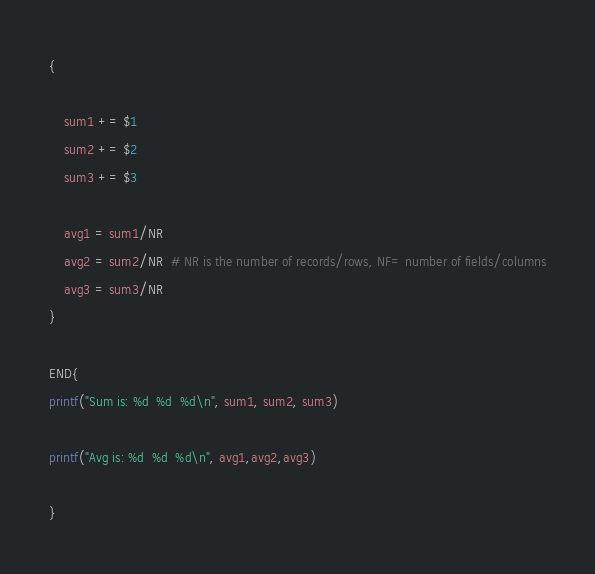Convert code to text. <code><loc_0><loc_0><loc_500><loc_500><_Awk_>

{

	sum1 += $1
	sum2 += $2
	sum3 += $3

	avg1 = sum1/NR
	avg2 = sum2/NR  # NR is the number of records/rows, NF= number of fields/columns
	avg3 = sum3/NR
}

END{
printf("Sum is: %d  %d  %d\n", sum1, sum2, sum3)

printf("Avg is: %d  %d  %d\n", avg1,avg2,avg3)

}
</code> 